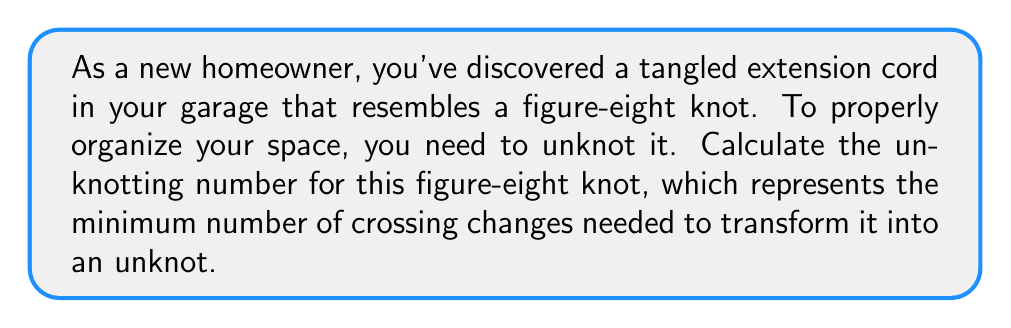Show me your answer to this math problem. To calculate the unknotting number for a figure-eight knot, we'll follow these steps:

1. Recognize the figure-eight knot:
   The figure-eight knot is also known as the 4₁ knot in knot theory notation.

2. Understand the unknotting number:
   The unknotting number is the minimum number of crossing changes required to transform a knot into an unknot (trivial knot).

3. Analyze the figure-eight knot structure:
   The figure-eight knot has four crossings in its standard diagram.

4. Consider the knot's properties:
   - The figure-eight knot is amphichiral (equivalent to its mirror image).
   - It has a crossing number of 4.

5. Apply known results:
   For alternating knots (like the figure-eight knot), the unknotting number is always less than or equal to half the crossing number.

6. Use the specific result for the figure-eight knot:
   It is known that the unknotting number of the figure-eight knot is exactly 1.

7. Visualize the unknotting process:
   Changing any one of the four crossings in the figure-eight knot diagram will result in the unknot.

Therefore, the unknotting number for the figure-eight knot is 1, meaning you need to make only one crossing change to unknot your tangled extension cord.
Answer: 1 